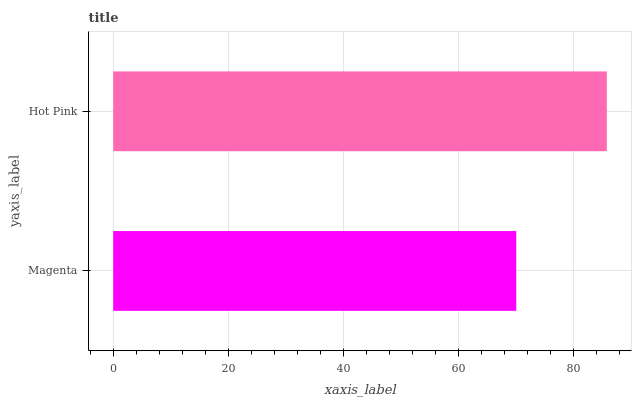Is Magenta the minimum?
Answer yes or no. Yes. Is Hot Pink the maximum?
Answer yes or no. Yes. Is Hot Pink the minimum?
Answer yes or no. No. Is Hot Pink greater than Magenta?
Answer yes or no. Yes. Is Magenta less than Hot Pink?
Answer yes or no. Yes. Is Magenta greater than Hot Pink?
Answer yes or no. No. Is Hot Pink less than Magenta?
Answer yes or no. No. Is Hot Pink the high median?
Answer yes or no. Yes. Is Magenta the low median?
Answer yes or no. Yes. Is Magenta the high median?
Answer yes or no. No. Is Hot Pink the low median?
Answer yes or no. No. 